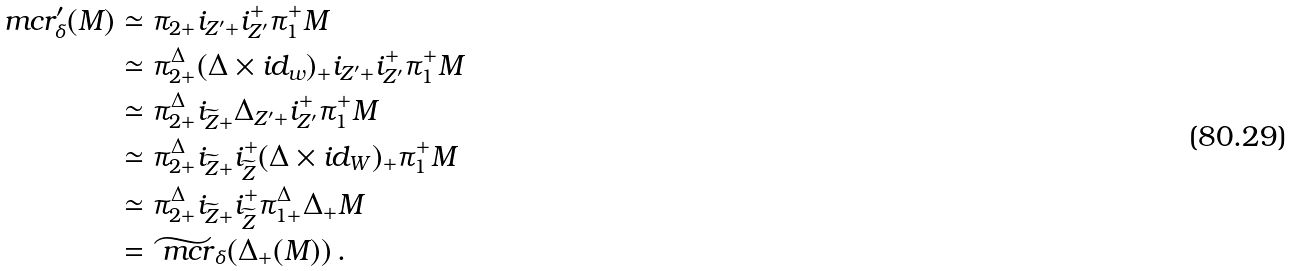<formula> <loc_0><loc_0><loc_500><loc_500>\ m c r ^ { \prime } _ { \delta } ( M ) & \simeq \pi _ { 2 + } i _ { Z ^ { \prime } + } i _ { Z ^ { \prime } } ^ { + } \pi _ { 1 } ^ { + } M \\ & \simeq \pi _ { 2 + } ^ { \Delta } ( \Delta \times i d _ { w } ) _ { + } i _ { Z ^ { \prime } + } i _ { Z ^ { \prime } } ^ { + } \pi _ { 1 } ^ { + } M \\ & \simeq \pi _ { 2 + } ^ { \Delta } i _ { \widetilde { Z } + } \Delta _ { Z ^ { \prime } + } i _ { Z ^ { \prime } } ^ { + } \pi _ { 1 } ^ { + } M \\ & \simeq \pi _ { 2 + } ^ { \Delta } i _ { \widetilde { Z } + } i _ { \widetilde { Z } } ^ { + } ( \Delta \times i d _ { W } ) _ { + } \pi _ { 1 } ^ { + } M \\ & \simeq \pi _ { 2 + } ^ { \Delta } i _ { \widetilde { Z } + } i _ { \widetilde { Z } } ^ { + } \pi _ { 1 + } ^ { \Delta } \Delta _ { + } M \\ & = \widetilde { \ m c r } _ { \delta } ( \Delta _ { + } ( M ) ) \, .</formula> 